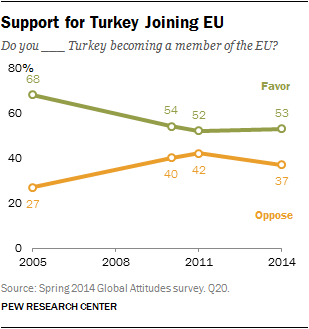Mention a couple of crucial points in this snapshot. The leftmost value of green in the graph is 68. The sum of the first three values of the orange graph is greater than 50. 